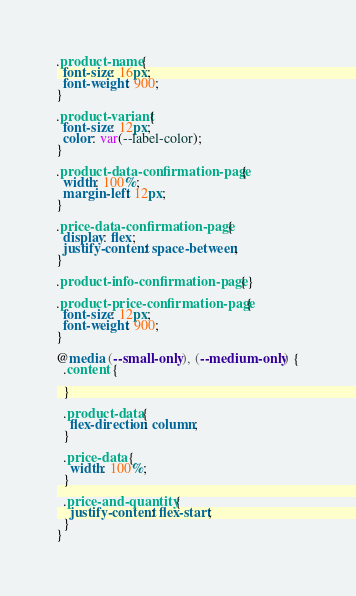<code> <loc_0><loc_0><loc_500><loc_500><_CSS_>.product-name {
  font-size: 16px;
  font-weight: 900;
}

.product-variant {
  font-size: 12px;
  color: var(--label-color);
}

.product-data-confirmation-page {
  width: 100%;
  margin-left: 12px;
}

.price-data-confirmation-page {
  display: flex;
  justify-content: space-between;
}

.product-info-confirmation-page {}

.product-price-confirmation-page {
  font-size: 12px;
  font-weight: 900;
}

@media (--small-only), (--medium-only) {
  .content {

  }

  .product-data {
    flex-direction: column;
  }

  .price-data {
    width: 100%;
  }

  .price-and-quantity {
    justify-content: flex-start;
  }
}
</code> 